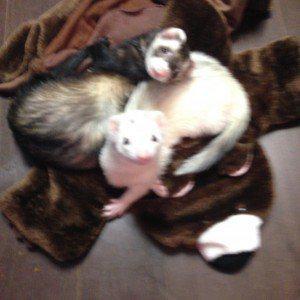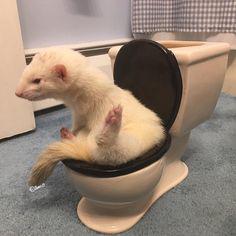The first image is the image on the left, the second image is the image on the right. Considering the images on both sides, is "There are more than 4 ferrets interacting." valid? Answer yes or no. No. The first image is the image on the left, the second image is the image on the right. For the images displayed, is the sentence "At least two ferrets are playing." factually correct? Answer yes or no. No. 